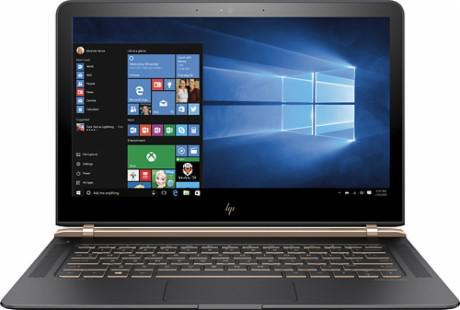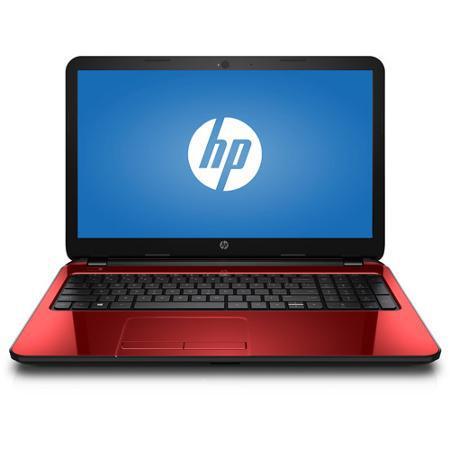The first image is the image on the left, the second image is the image on the right. Evaluate the accuracy of this statement regarding the images: "the laptop on the right image has a black background". Is it true? Answer yes or no. No. 